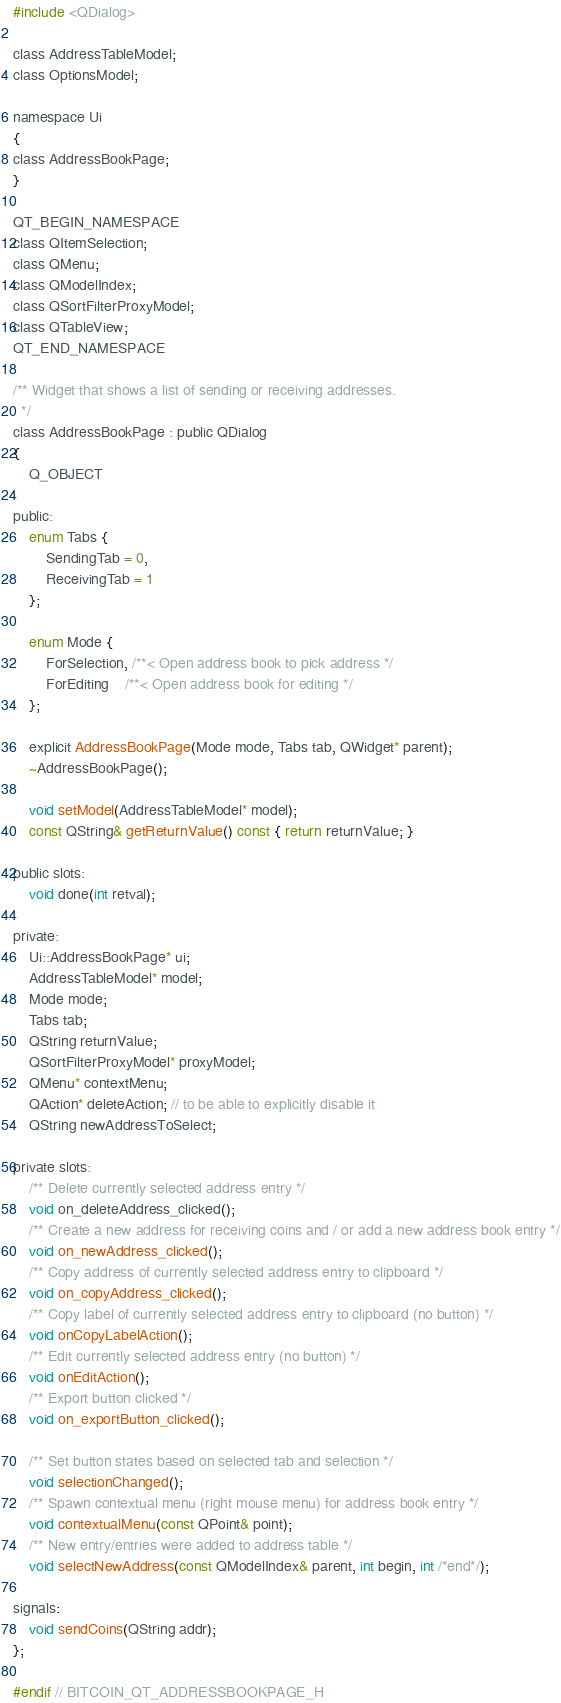Convert code to text. <code><loc_0><loc_0><loc_500><loc_500><_C_>
#include <QDialog>

class AddressTableModel;
class OptionsModel;

namespace Ui
{
class AddressBookPage;
}

QT_BEGIN_NAMESPACE
class QItemSelection;
class QMenu;
class QModelIndex;
class QSortFilterProxyModel;
class QTableView;
QT_END_NAMESPACE

/** Widget that shows a list of sending or receiving addresses.
  */
class AddressBookPage : public QDialog
{
    Q_OBJECT

public:
    enum Tabs {
        SendingTab = 0,
        ReceivingTab = 1
    };

    enum Mode {
        ForSelection, /**< Open address book to pick address */
        ForEditing    /**< Open address book for editing */
    };

    explicit AddressBookPage(Mode mode, Tabs tab, QWidget* parent);
    ~AddressBookPage();

    void setModel(AddressTableModel* model);
    const QString& getReturnValue() const { return returnValue; }

public slots:
    void done(int retval);

private:
    Ui::AddressBookPage* ui;
    AddressTableModel* model;
    Mode mode;
    Tabs tab;
    QString returnValue;
    QSortFilterProxyModel* proxyModel;
    QMenu* contextMenu;
    QAction* deleteAction; // to be able to explicitly disable it
    QString newAddressToSelect;

private slots:
    /** Delete currently selected address entry */
    void on_deleteAddress_clicked();
    /** Create a new address for receiving coins and / or add a new address book entry */
    void on_newAddress_clicked();
    /** Copy address of currently selected address entry to clipboard */
    void on_copyAddress_clicked();
    /** Copy label of currently selected address entry to clipboard (no button) */
    void onCopyLabelAction();
    /** Edit currently selected address entry (no button) */
    void onEditAction();
    /** Export button clicked */
    void on_exportButton_clicked();

    /** Set button states based on selected tab and selection */
    void selectionChanged();
    /** Spawn contextual menu (right mouse menu) for address book entry */
    void contextualMenu(const QPoint& point);
    /** New entry/entries were added to address table */
    void selectNewAddress(const QModelIndex& parent, int begin, int /*end*/);

signals:
    void sendCoins(QString addr);
};

#endif // BITCOIN_QT_ADDRESSBOOKPAGE_H
</code> 